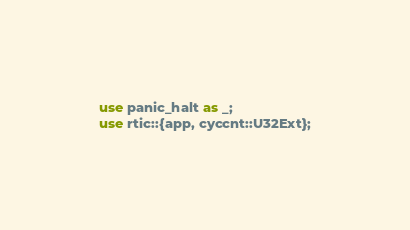<code> <loc_0><loc_0><loc_500><loc_500><_Rust_>
use panic_halt as _;
use rtic::{app, cyccnt::U32Ext};</code> 